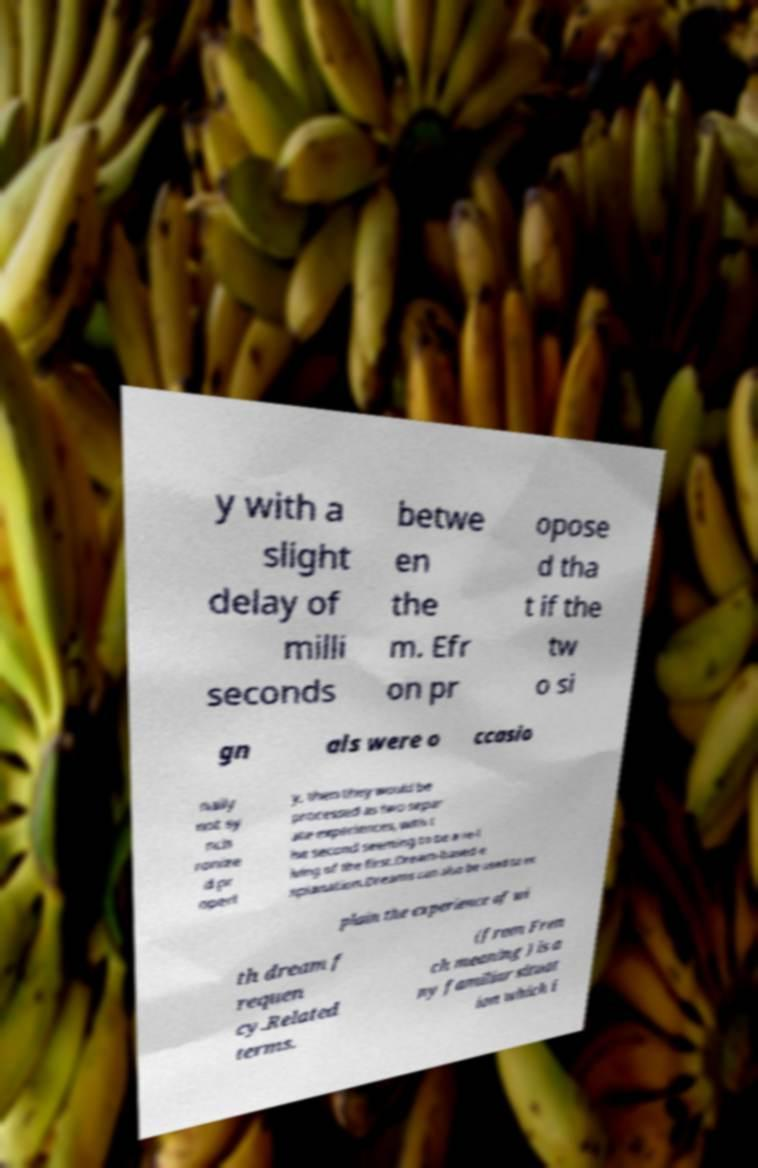Please read and relay the text visible in this image. What does it say? y with a slight delay of milli seconds betwe en the m. Efr on pr opose d tha t if the tw o si gn als were o ccasio nally not sy nch ronize d pr operl y, then they would be processed as two separ ate experiences, with t he second seeming to be a re-l iving of the first.Dream-based e xplanation.Dreams can also be used to ex plain the experience of wi th dream f requen cy.Related terms. (from Fren ch meaning ) is a ny familiar situat ion which i 